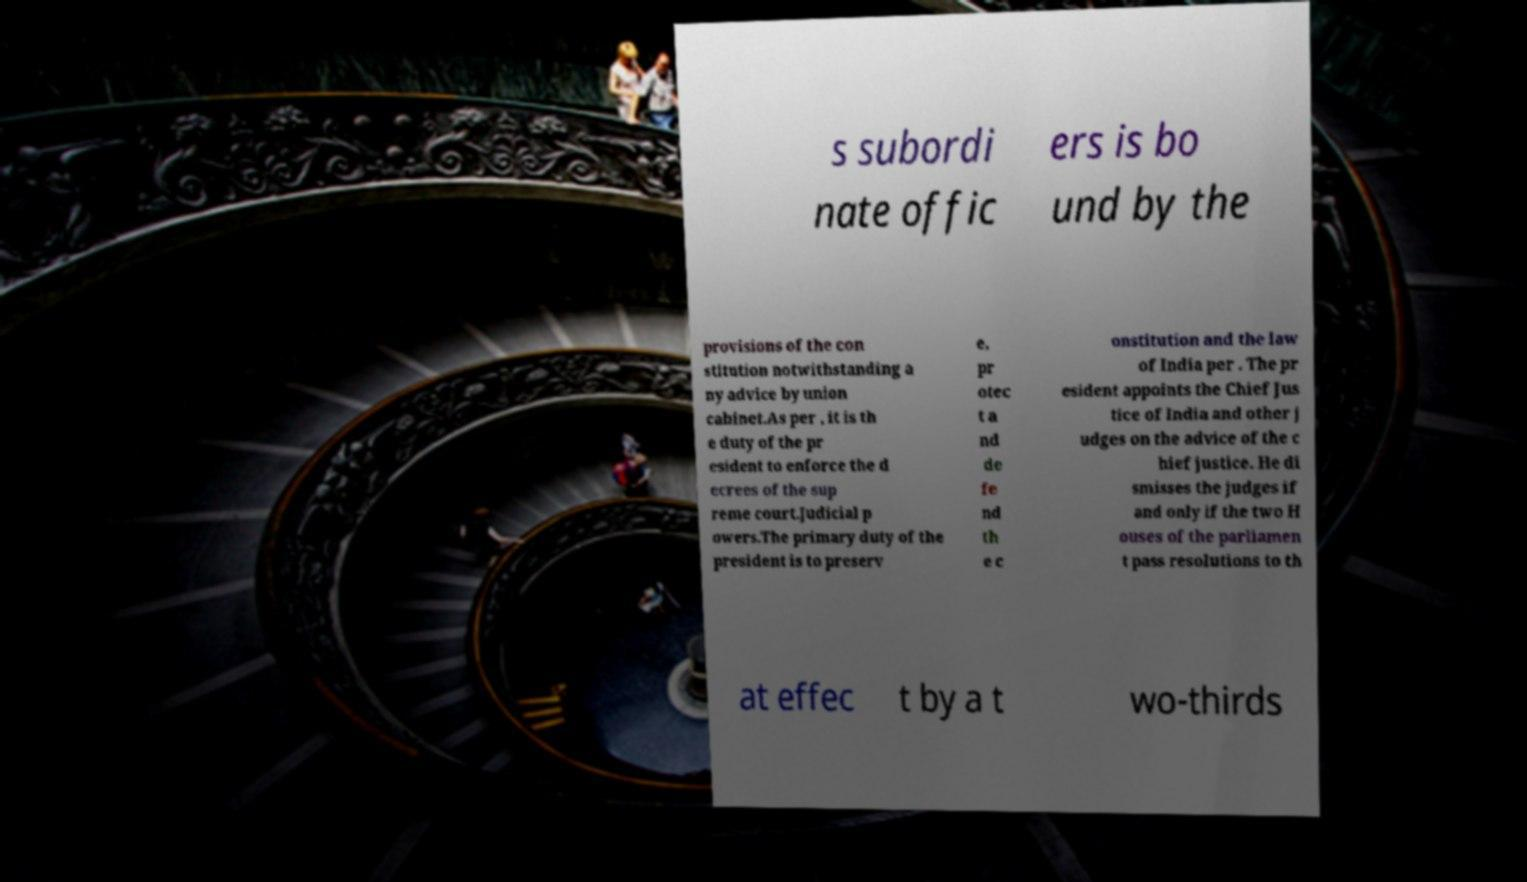Please identify and transcribe the text found in this image. s subordi nate offic ers is bo und by the provisions of the con stitution notwithstanding a ny advice by union cabinet.As per , it is th e duty of the pr esident to enforce the d ecrees of the sup reme court.Judicial p owers.The primary duty of the president is to preserv e, pr otec t a nd de fe nd th e c onstitution and the law of India per . The pr esident appoints the Chief Jus tice of India and other j udges on the advice of the c hief justice. He di smisses the judges if and only if the two H ouses of the parliamen t pass resolutions to th at effec t by a t wo-thirds 